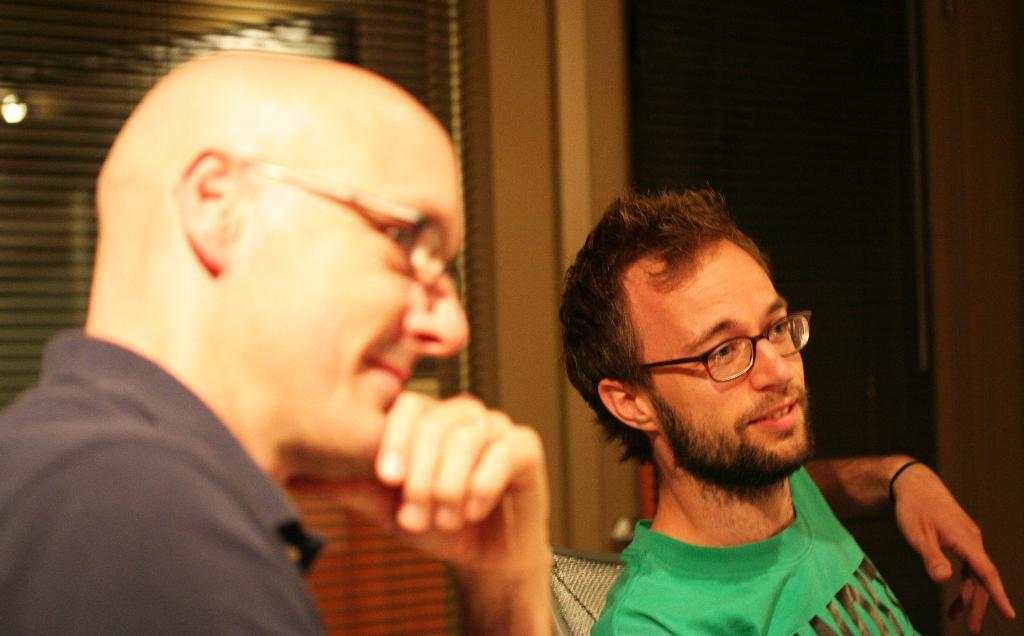What is located on the left side of the image? There is a man on the left side of the image. What can be seen on the man's face? The man is wearing spectacles. What type of clothing is the man wearing? The man is wearing a t-shirt. What is located on the right side of the image? There is a person on the right side of the image. What color is the t-shirt worn by the person on the right side? The person on the right side is wearing a green color t-shirt. How many wax chickens are present on the table in the image? There is no table or wax chickens present in the image. 